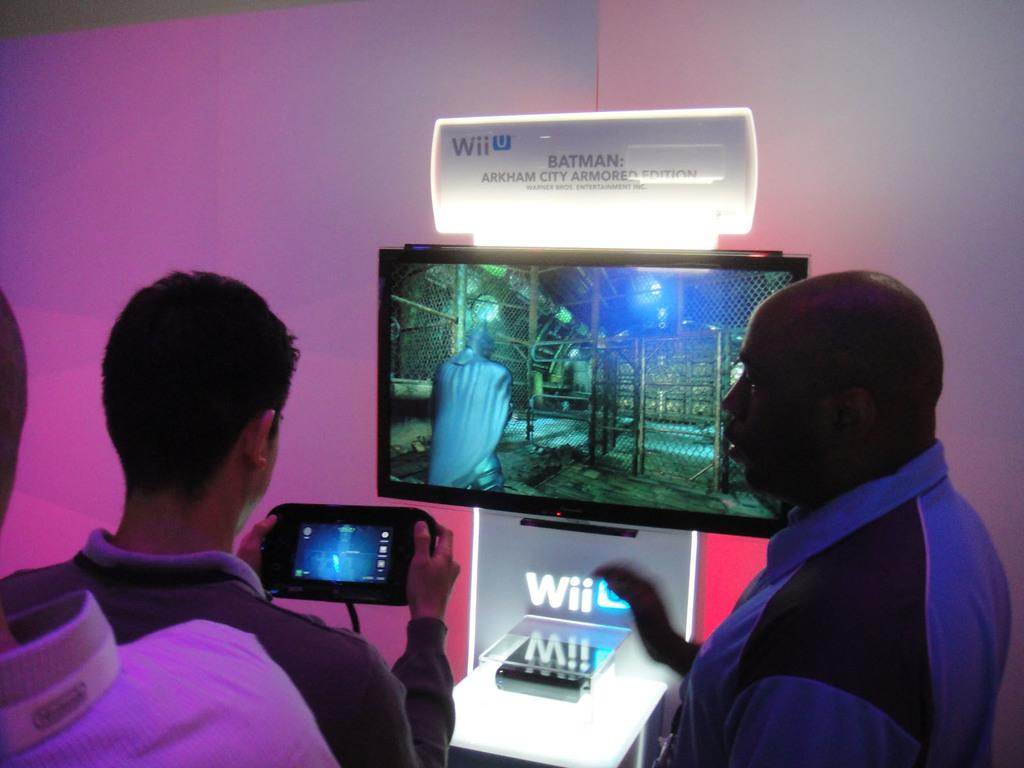<image>
Share a concise interpretation of the image provided. People are gathered around a display where one person is playing Batman: Arkham City Armored Edition on a Wii U. 